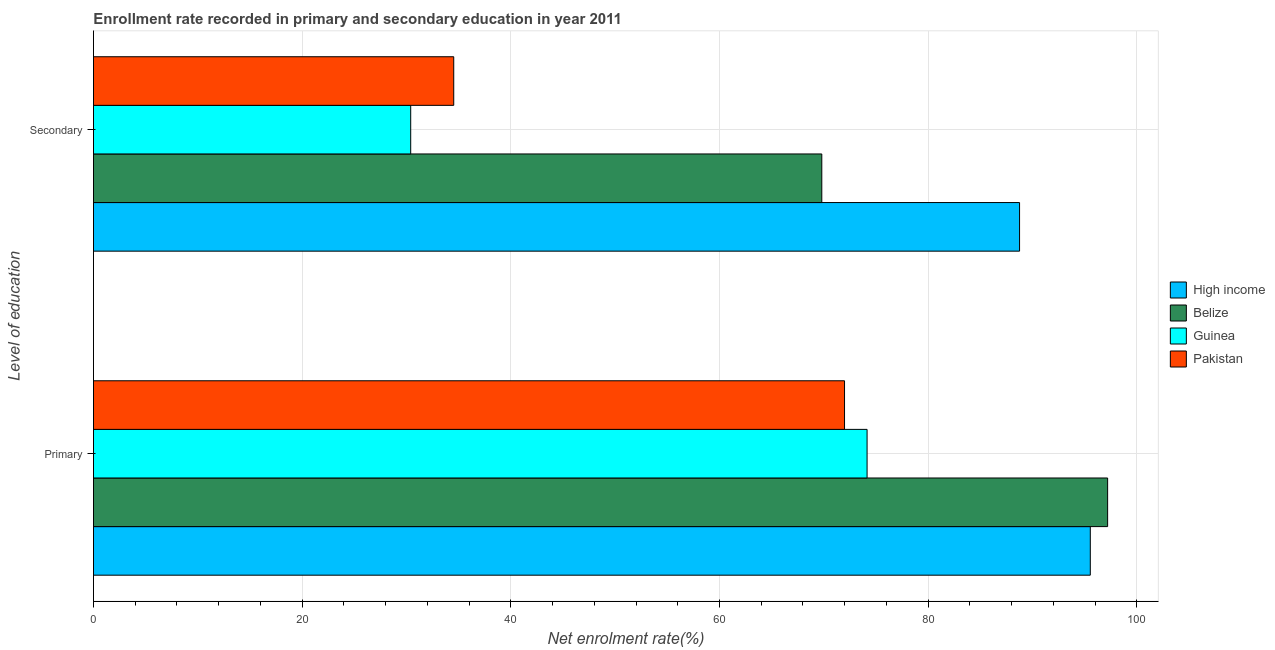How many different coloured bars are there?
Your answer should be very brief. 4. Are the number of bars per tick equal to the number of legend labels?
Offer a very short reply. Yes. How many bars are there on the 2nd tick from the bottom?
Provide a short and direct response. 4. What is the label of the 2nd group of bars from the top?
Keep it short and to the point. Primary. What is the enrollment rate in secondary education in Pakistan?
Your answer should be compact. 34.53. Across all countries, what is the maximum enrollment rate in secondary education?
Offer a terse response. 88.76. Across all countries, what is the minimum enrollment rate in primary education?
Ensure brevity in your answer.  71.98. In which country was the enrollment rate in primary education maximum?
Keep it short and to the point. Belize. In which country was the enrollment rate in secondary education minimum?
Ensure brevity in your answer.  Guinea. What is the total enrollment rate in secondary education in the graph?
Offer a very short reply. 223.5. What is the difference between the enrollment rate in secondary education in High income and that in Guinea?
Keep it short and to the point. 58.35. What is the difference between the enrollment rate in primary education in Pakistan and the enrollment rate in secondary education in Guinea?
Offer a very short reply. 41.58. What is the average enrollment rate in secondary education per country?
Keep it short and to the point. 55.88. What is the difference between the enrollment rate in primary education and enrollment rate in secondary education in Guinea?
Keep it short and to the point. 43.74. What is the ratio of the enrollment rate in primary education in High income to that in Pakistan?
Ensure brevity in your answer.  1.33. What does the 1st bar from the top in Secondary represents?
Your response must be concise. Pakistan. What does the 3rd bar from the bottom in Secondary represents?
Your answer should be very brief. Guinea. Are all the bars in the graph horizontal?
Ensure brevity in your answer.  Yes. How many countries are there in the graph?
Keep it short and to the point. 4. Does the graph contain any zero values?
Provide a short and direct response. No. How many legend labels are there?
Offer a very short reply. 4. How are the legend labels stacked?
Make the answer very short. Vertical. What is the title of the graph?
Ensure brevity in your answer.  Enrollment rate recorded in primary and secondary education in year 2011. What is the label or title of the X-axis?
Ensure brevity in your answer.  Net enrolment rate(%). What is the label or title of the Y-axis?
Your answer should be very brief. Level of education. What is the Net enrolment rate(%) in High income in Primary?
Keep it short and to the point. 95.54. What is the Net enrolment rate(%) in Belize in Primary?
Your answer should be very brief. 97.2. What is the Net enrolment rate(%) of Guinea in Primary?
Your response must be concise. 74.15. What is the Net enrolment rate(%) in Pakistan in Primary?
Provide a succinct answer. 71.98. What is the Net enrolment rate(%) in High income in Secondary?
Give a very brief answer. 88.76. What is the Net enrolment rate(%) of Belize in Secondary?
Your answer should be very brief. 69.81. What is the Net enrolment rate(%) in Guinea in Secondary?
Provide a short and direct response. 30.41. What is the Net enrolment rate(%) in Pakistan in Secondary?
Make the answer very short. 34.53. Across all Level of education, what is the maximum Net enrolment rate(%) of High income?
Your answer should be compact. 95.54. Across all Level of education, what is the maximum Net enrolment rate(%) of Belize?
Keep it short and to the point. 97.2. Across all Level of education, what is the maximum Net enrolment rate(%) of Guinea?
Your answer should be compact. 74.15. Across all Level of education, what is the maximum Net enrolment rate(%) of Pakistan?
Provide a short and direct response. 71.98. Across all Level of education, what is the minimum Net enrolment rate(%) of High income?
Provide a succinct answer. 88.76. Across all Level of education, what is the minimum Net enrolment rate(%) in Belize?
Provide a succinct answer. 69.81. Across all Level of education, what is the minimum Net enrolment rate(%) in Guinea?
Offer a very short reply. 30.41. Across all Level of education, what is the minimum Net enrolment rate(%) in Pakistan?
Your response must be concise. 34.53. What is the total Net enrolment rate(%) in High income in the graph?
Give a very brief answer. 184.3. What is the total Net enrolment rate(%) in Belize in the graph?
Make the answer very short. 167.01. What is the total Net enrolment rate(%) in Guinea in the graph?
Offer a very short reply. 104.55. What is the total Net enrolment rate(%) in Pakistan in the graph?
Your response must be concise. 106.51. What is the difference between the Net enrolment rate(%) in High income in Primary and that in Secondary?
Your response must be concise. 6.78. What is the difference between the Net enrolment rate(%) of Belize in Primary and that in Secondary?
Make the answer very short. 27.4. What is the difference between the Net enrolment rate(%) of Guinea in Primary and that in Secondary?
Offer a terse response. 43.74. What is the difference between the Net enrolment rate(%) in Pakistan in Primary and that in Secondary?
Your answer should be very brief. 37.46. What is the difference between the Net enrolment rate(%) in High income in Primary and the Net enrolment rate(%) in Belize in Secondary?
Offer a terse response. 25.73. What is the difference between the Net enrolment rate(%) of High income in Primary and the Net enrolment rate(%) of Guinea in Secondary?
Give a very brief answer. 65.13. What is the difference between the Net enrolment rate(%) of High income in Primary and the Net enrolment rate(%) of Pakistan in Secondary?
Your response must be concise. 61.01. What is the difference between the Net enrolment rate(%) of Belize in Primary and the Net enrolment rate(%) of Guinea in Secondary?
Give a very brief answer. 66.8. What is the difference between the Net enrolment rate(%) in Belize in Primary and the Net enrolment rate(%) in Pakistan in Secondary?
Give a very brief answer. 62.67. What is the difference between the Net enrolment rate(%) of Guinea in Primary and the Net enrolment rate(%) of Pakistan in Secondary?
Your answer should be compact. 39.62. What is the average Net enrolment rate(%) of High income per Level of education?
Your answer should be compact. 92.15. What is the average Net enrolment rate(%) in Belize per Level of education?
Your answer should be compact. 83.5. What is the average Net enrolment rate(%) of Guinea per Level of education?
Ensure brevity in your answer.  52.28. What is the average Net enrolment rate(%) in Pakistan per Level of education?
Keep it short and to the point. 53.26. What is the difference between the Net enrolment rate(%) in High income and Net enrolment rate(%) in Belize in Primary?
Make the answer very short. -1.66. What is the difference between the Net enrolment rate(%) in High income and Net enrolment rate(%) in Guinea in Primary?
Keep it short and to the point. 21.39. What is the difference between the Net enrolment rate(%) of High income and Net enrolment rate(%) of Pakistan in Primary?
Give a very brief answer. 23.56. What is the difference between the Net enrolment rate(%) in Belize and Net enrolment rate(%) in Guinea in Primary?
Your response must be concise. 23.06. What is the difference between the Net enrolment rate(%) of Belize and Net enrolment rate(%) of Pakistan in Primary?
Provide a succinct answer. 25.22. What is the difference between the Net enrolment rate(%) in Guinea and Net enrolment rate(%) in Pakistan in Primary?
Ensure brevity in your answer.  2.16. What is the difference between the Net enrolment rate(%) of High income and Net enrolment rate(%) of Belize in Secondary?
Make the answer very short. 18.95. What is the difference between the Net enrolment rate(%) of High income and Net enrolment rate(%) of Guinea in Secondary?
Keep it short and to the point. 58.35. What is the difference between the Net enrolment rate(%) of High income and Net enrolment rate(%) of Pakistan in Secondary?
Offer a very short reply. 54.23. What is the difference between the Net enrolment rate(%) in Belize and Net enrolment rate(%) in Guinea in Secondary?
Give a very brief answer. 39.4. What is the difference between the Net enrolment rate(%) in Belize and Net enrolment rate(%) in Pakistan in Secondary?
Keep it short and to the point. 35.28. What is the difference between the Net enrolment rate(%) of Guinea and Net enrolment rate(%) of Pakistan in Secondary?
Offer a very short reply. -4.12. What is the ratio of the Net enrolment rate(%) of High income in Primary to that in Secondary?
Provide a succinct answer. 1.08. What is the ratio of the Net enrolment rate(%) of Belize in Primary to that in Secondary?
Provide a succinct answer. 1.39. What is the ratio of the Net enrolment rate(%) in Guinea in Primary to that in Secondary?
Make the answer very short. 2.44. What is the ratio of the Net enrolment rate(%) in Pakistan in Primary to that in Secondary?
Provide a short and direct response. 2.08. What is the difference between the highest and the second highest Net enrolment rate(%) of High income?
Give a very brief answer. 6.78. What is the difference between the highest and the second highest Net enrolment rate(%) in Belize?
Give a very brief answer. 27.4. What is the difference between the highest and the second highest Net enrolment rate(%) of Guinea?
Your response must be concise. 43.74. What is the difference between the highest and the second highest Net enrolment rate(%) in Pakistan?
Give a very brief answer. 37.46. What is the difference between the highest and the lowest Net enrolment rate(%) in High income?
Ensure brevity in your answer.  6.78. What is the difference between the highest and the lowest Net enrolment rate(%) of Belize?
Your answer should be very brief. 27.4. What is the difference between the highest and the lowest Net enrolment rate(%) in Guinea?
Keep it short and to the point. 43.74. What is the difference between the highest and the lowest Net enrolment rate(%) in Pakistan?
Ensure brevity in your answer.  37.46. 